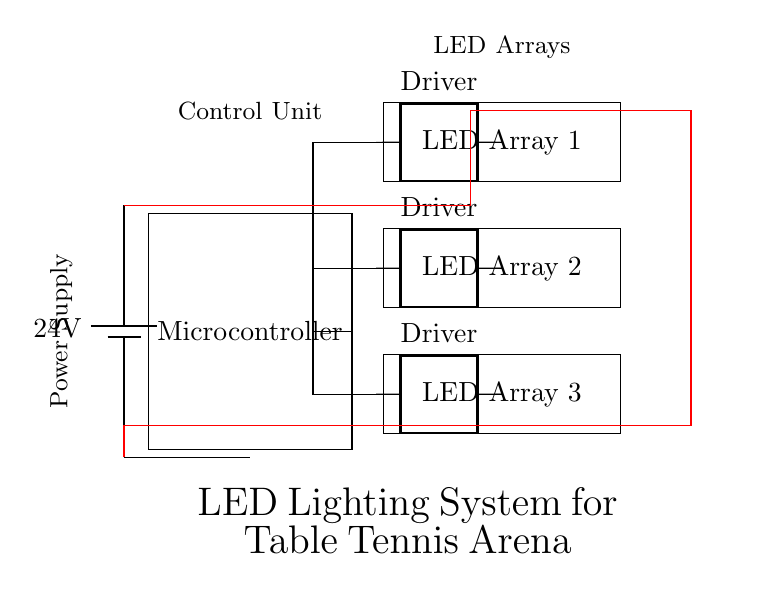What is the power supply voltage? The circuit shows a battery labeled with a voltage of 24V, indicating the power supply for the system.
Answer: 24V How many LED arrays are in the circuit? The diagram displays three distinct rectangles labeled as LED Array 1, LED Array 2, and LED Array 3, confirming there are three LED arrays included.
Answer: 3 What component is used to drive the LED arrays? The circuit indicates "Driver" next to three sets of connections to the LED arrays, suggesting that these drivers are responsible for operating the LED arrays.
Answer: Driver Which component controls the LED lighting patterns? The microcontroller is positioned in the center and connected to the LED drivers, indicating that it manages the lighting patterns and their programming.
Answer: Microcontroller How are the LED arrays powered? The circuit layout shows that each LED driver receives power from a common power supply, linking back to the battery, which suggests they are powered directly from the power supply via the drivers.
Answer: Through drivers What kind of circuit is this primarily? The components and layout suggest this is an LED lighting control circuit specifically designed for a table tennis arena, focusing on programmable patterns for illumination.
Answer: LED lighting control circuit 